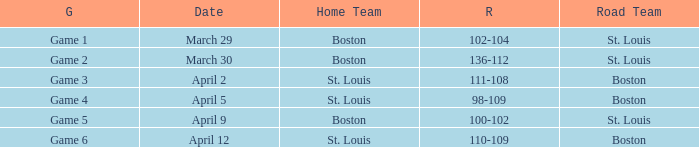What is the Result of the Game on April 9? 100-102. 